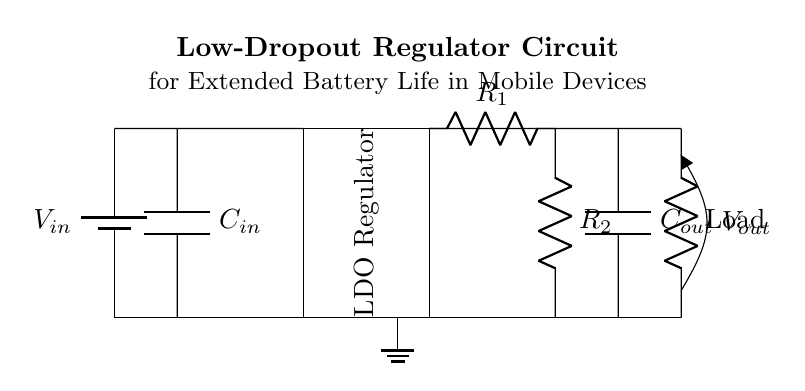What type of capacitor is used at the input? The input capacitor, labeled C in the diagram, is identified by the symbol and typically functionality. In the circuit, its main purpose is to stabilize the input voltage and reduce high-frequency noise. It can be classified as a decoupling capacitor.
Answer: C in What is the output voltage of this regulator circuit? The regulator circuit is designed to provide a stable output voltage (Vout), which is often lower than the input voltage (Vin). To determine the specific output voltage, we'd typically refer to the feedback resistors' configuration, which is often designed to achieve a certain desired output level based on their ratio. The precise value isn't provided in the text but would depend on component values.
Answer: Not specified How many resistors are present in the feedback loop? The circuit contains two resistors labeled R1 and R2 in the feedback loop, which is essential in setting the output voltage level of the regulator. The feedback loop is necessary for maintaining the desired output in LDO circuits.
Answer: Two What is the role of the output capacitor in the circuit? The output capacitor in this circuit, labeled Cout, has a crucial role in stabilizing the output voltage under varying load conditions and filtering any ripples in the output. Its placement after the load highlights this purpose of smoothing the voltage and providing transient response improvements.
Answer: Stabilization What is the function of the LDO regulator in this configuration? The Low-Dropout Regulator (LDO) is designed to maintain a constant output voltage with minimal voltage drop (Vin to Vout). It allows the connected load to receive power even when the input voltage isn't dramatically higher than the output. This is especially beneficial in battery-powered devices to maximize battery life.
Answer: Voltage regulation 